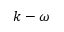<formula> <loc_0><loc_0><loc_500><loc_500>k - \omega</formula> 